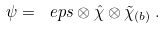<formula> <loc_0><loc_0><loc_500><loc_500>\psi = \ e p s \otimes \hat { \chi } \otimes \tilde { \chi } _ { ( b ) } \, .</formula> 